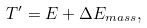Convert formula to latex. <formula><loc_0><loc_0><loc_500><loc_500>T ^ { \prime } = E + \Delta E _ { m a s s } ,</formula> 